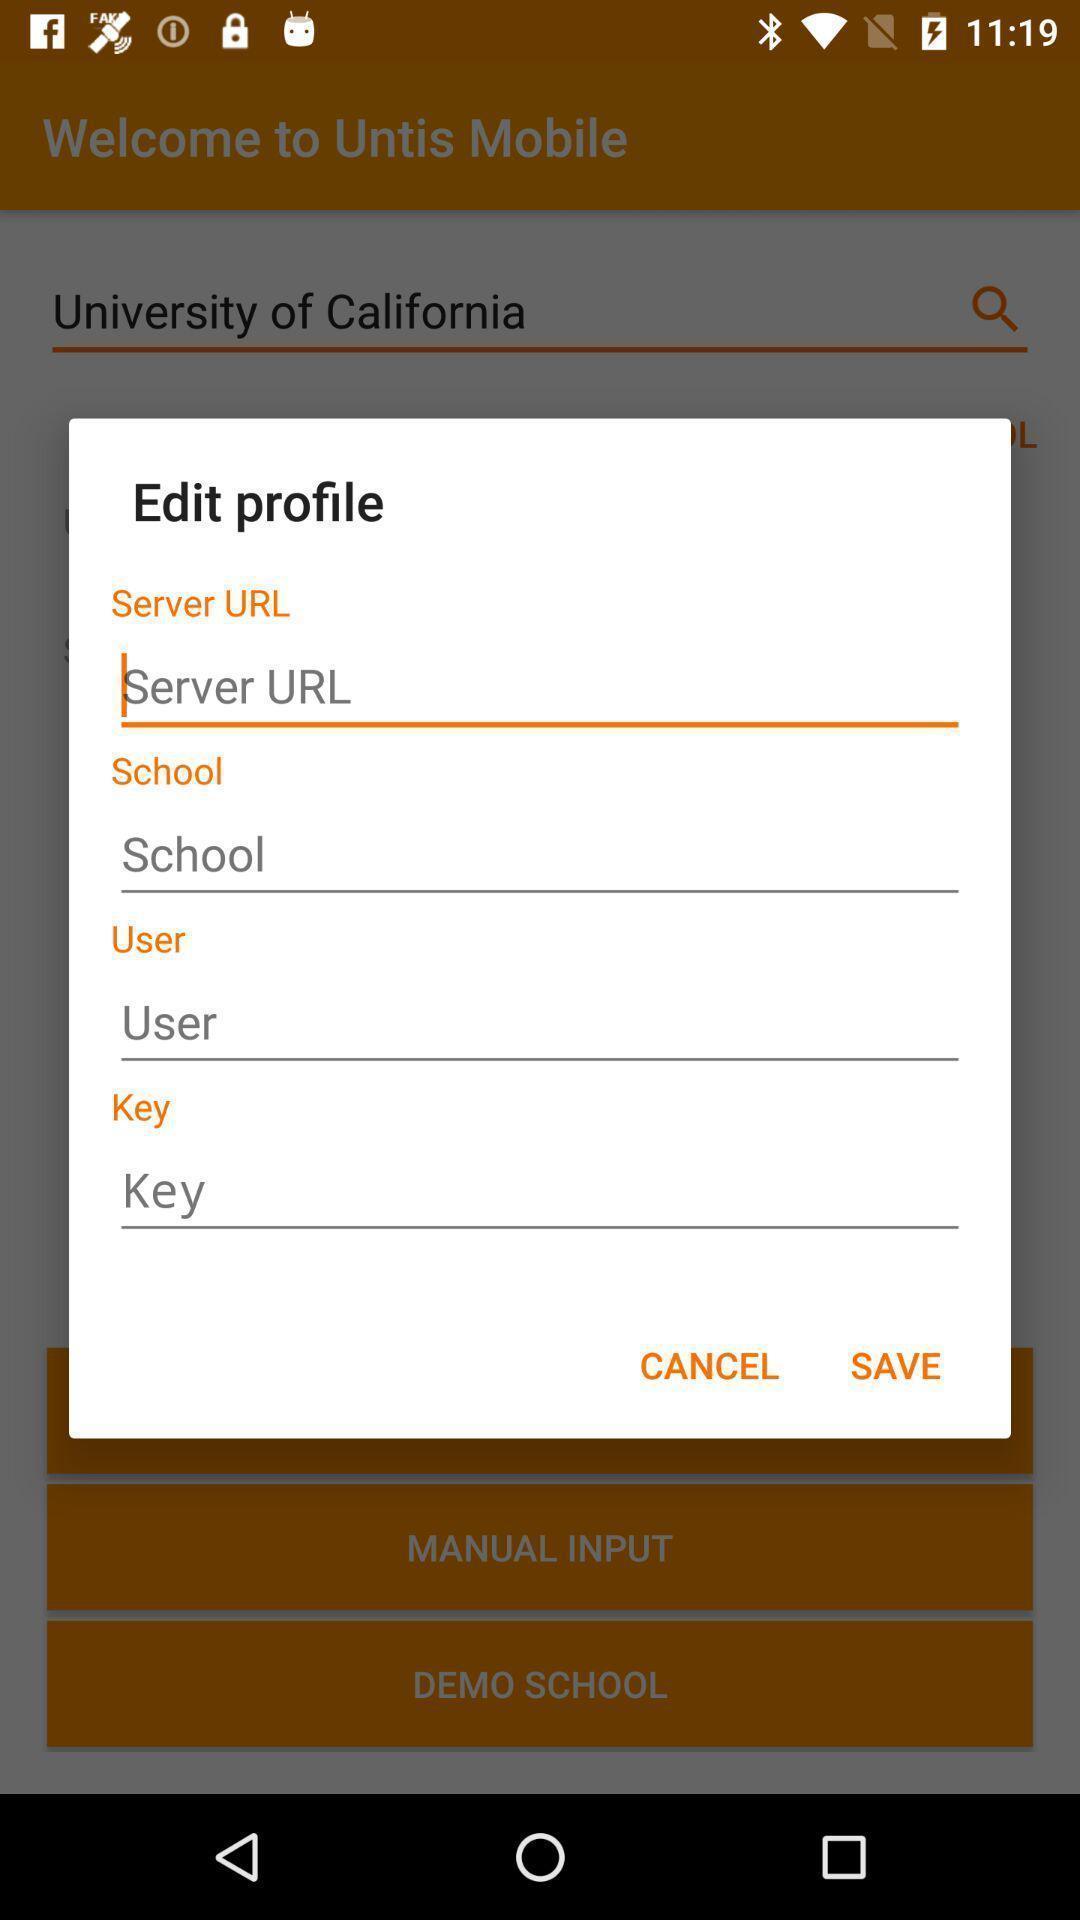What details can you identify in this image? Push up message to edit profile. 